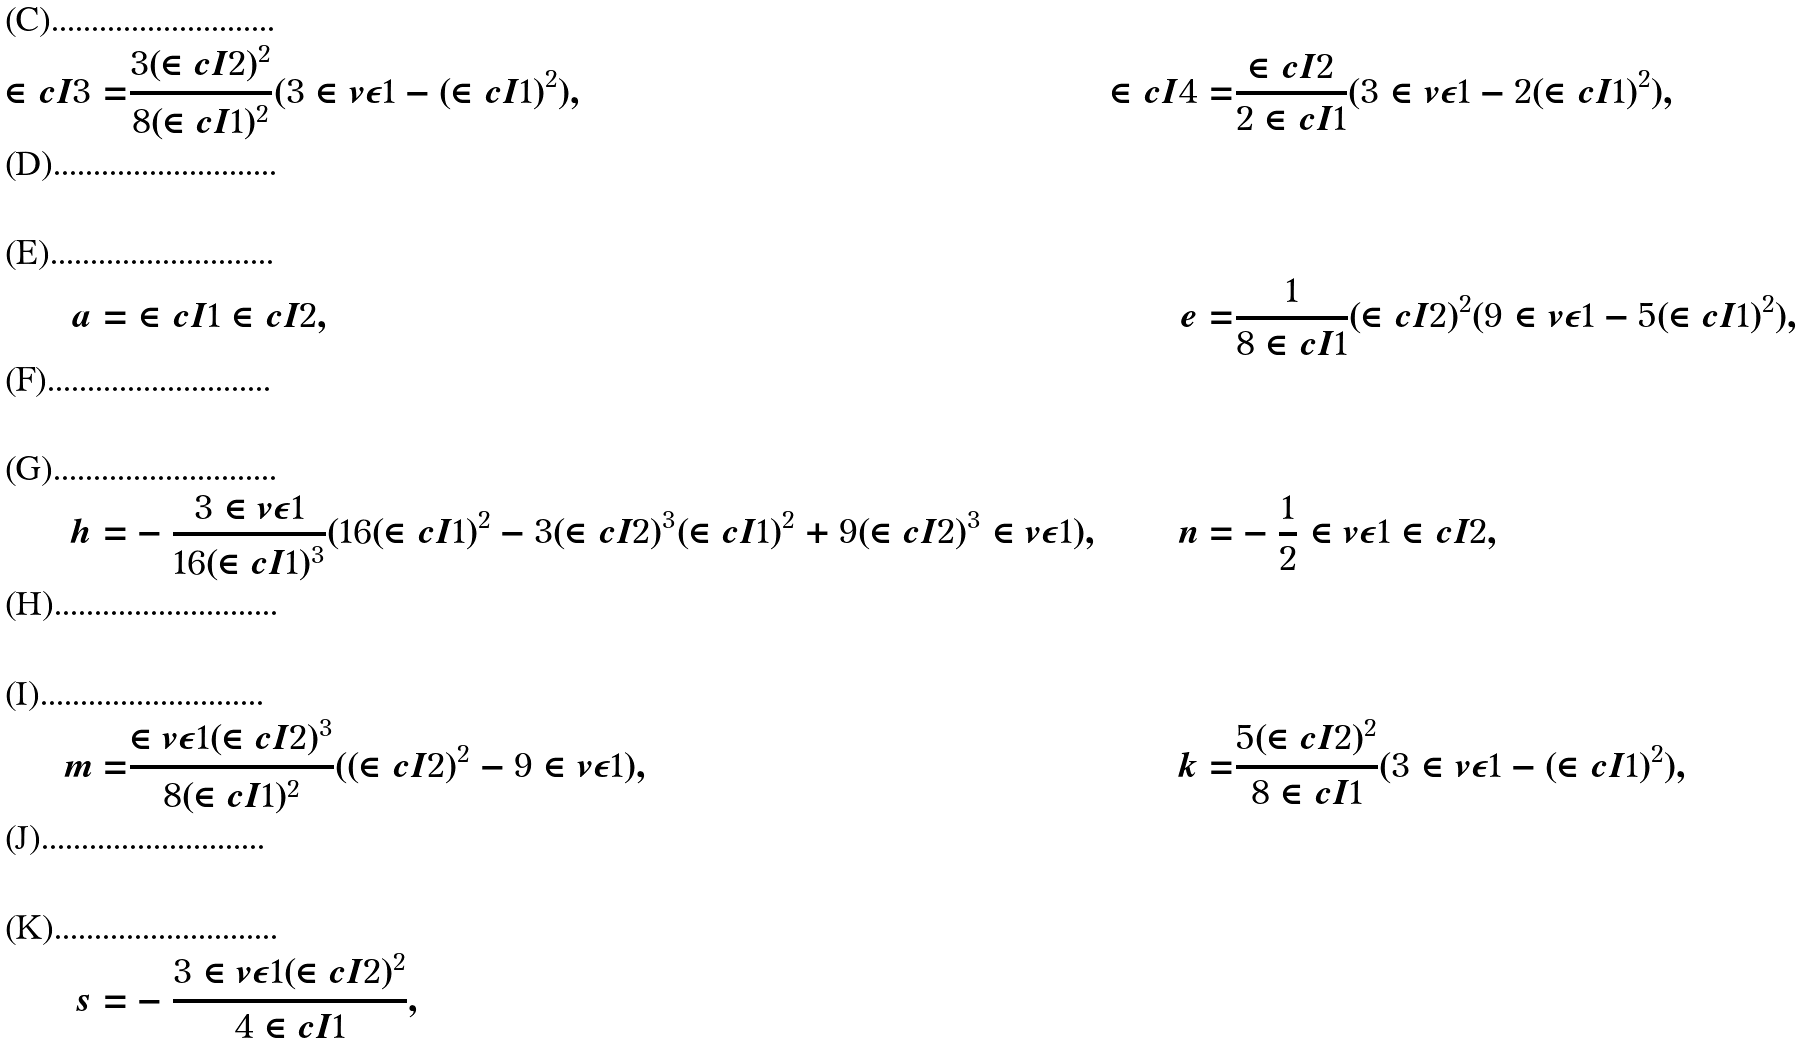Convert formula to latex. <formula><loc_0><loc_0><loc_500><loc_500>\in c { I } { 3 } = & \frac { 3 ( \in c { I } { 2 } ) ^ { 2 } } { 8 ( \in c { I } { 1 } ) ^ { 2 } } ( 3 \in v { \epsilon } { 1 } - ( \in c { I } { 1 } ) ^ { 2 } ) , & \in c { I } { 4 } = & \frac { \in c { I } { 2 } } { 2 \in c { I } { 1 } } ( 3 \in v { \epsilon } { 1 } - 2 ( \in c { I } { 1 } ) ^ { 2 } ) , \\ \\ a = & \in c { I } { 1 } \in c { I } { 2 } , & e = & \frac { 1 } { 8 \in c { I } { 1 } } ( \in c { I } { 2 } ) ^ { 2 } ( 9 \in v { \epsilon } { 1 } - 5 ( \in c { I } { 1 } ) ^ { 2 } ) , \\ \\ h = & - \frac { 3 \in v { \epsilon } { 1 } } { 1 6 ( \in c { I } { 1 } ) ^ { 3 } } ( 1 6 ( \in c { I } { 1 } ) ^ { 2 } - 3 ( \in c { I } { 2 } ) ^ { 3 } ( \in c { I } { 1 } ) ^ { 2 } + 9 ( \in c { I } { 2 } ) ^ { 3 } \in v { \epsilon } { 1 } ) , & n = & - \frac { 1 } { 2 } \in v { \epsilon } { 1 } \in c { I } { 2 } , \\ \\ m = & \frac { \in v { \epsilon } { 1 } ( \in c { I } { 2 } ) ^ { 3 } } { 8 ( \in c { I } { 1 } ) ^ { 2 } } ( ( \in c { I } { 2 } ) ^ { 2 } - 9 \in v { \epsilon } { 1 } ) , & k = & \frac { 5 ( \in c { I } { 2 } ) ^ { 2 } } { 8 \in c { I } { 1 } } ( 3 \in v { \epsilon } { 1 } - ( \in c { I } { 1 } ) ^ { 2 } ) , \\ \\ s = & - \frac { 3 \in v { \epsilon } { 1 } ( \in c { I } { 2 } ) ^ { 2 } } { 4 \in c { I } { 1 } } , & &</formula> 